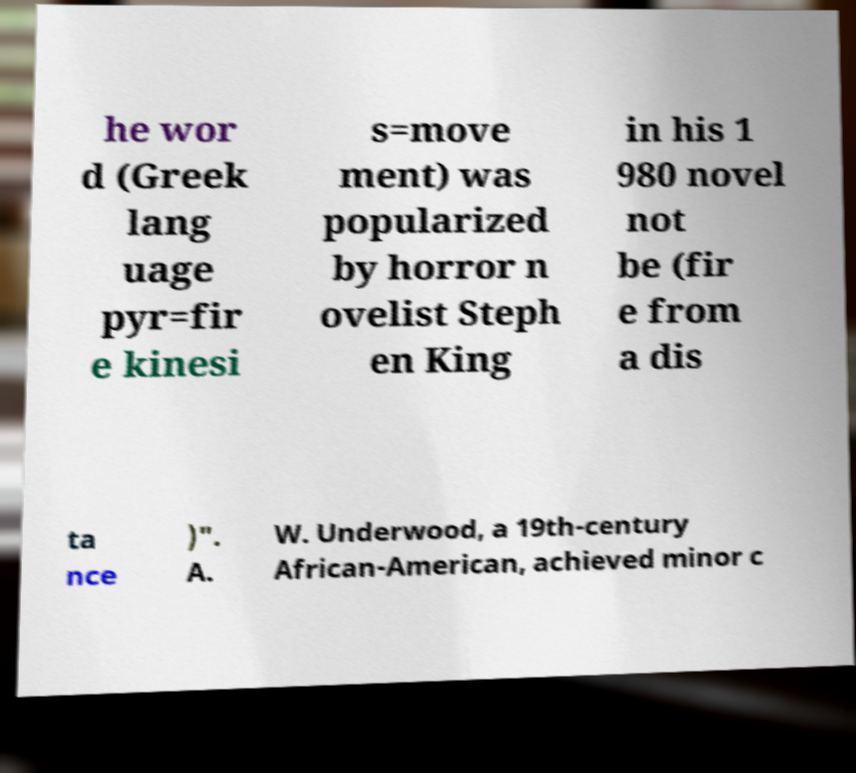Can you accurately transcribe the text from the provided image for me? he wor d (Greek lang uage pyr=fir e kinesi s=move ment) was popularized by horror n ovelist Steph en King in his 1 980 novel not be (fir e from a dis ta nce )". A. W. Underwood, a 19th-century African-American, achieved minor c 